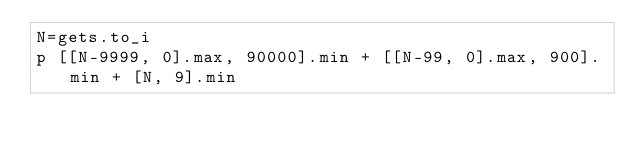<code> <loc_0><loc_0><loc_500><loc_500><_Ruby_>N=gets.to_i
p [[N-9999, 0].max, 90000].min + [[N-99, 0].max, 900].min + [N, 9].min</code> 